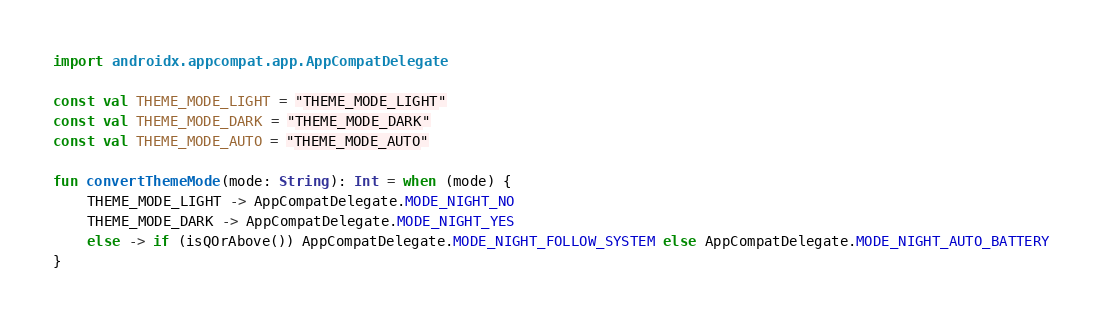Convert code to text. <code><loc_0><loc_0><loc_500><loc_500><_Kotlin_>import androidx.appcompat.app.AppCompatDelegate

const val THEME_MODE_LIGHT = "THEME_MODE_LIGHT"
const val THEME_MODE_DARK = "THEME_MODE_DARK"
const val THEME_MODE_AUTO = "THEME_MODE_AUTO"

fun convertThemeMode(mode: String): Int = when (mode) {
    THEME_MODE_LIGHT -> AppCompatDelegate.MODE_NIGHT_NO
    THEME_MODE_DARK -> AppCompatDelegate.MODE_NIGHT_YES
    else -> if (isQOrAbove()) AppCompatDelegate.MODE_NIGHT_FOLLOW_SYSTEM else AppCompatDelegate.MODE_NIGHT_AUTO_BATTERY
}
</code> 